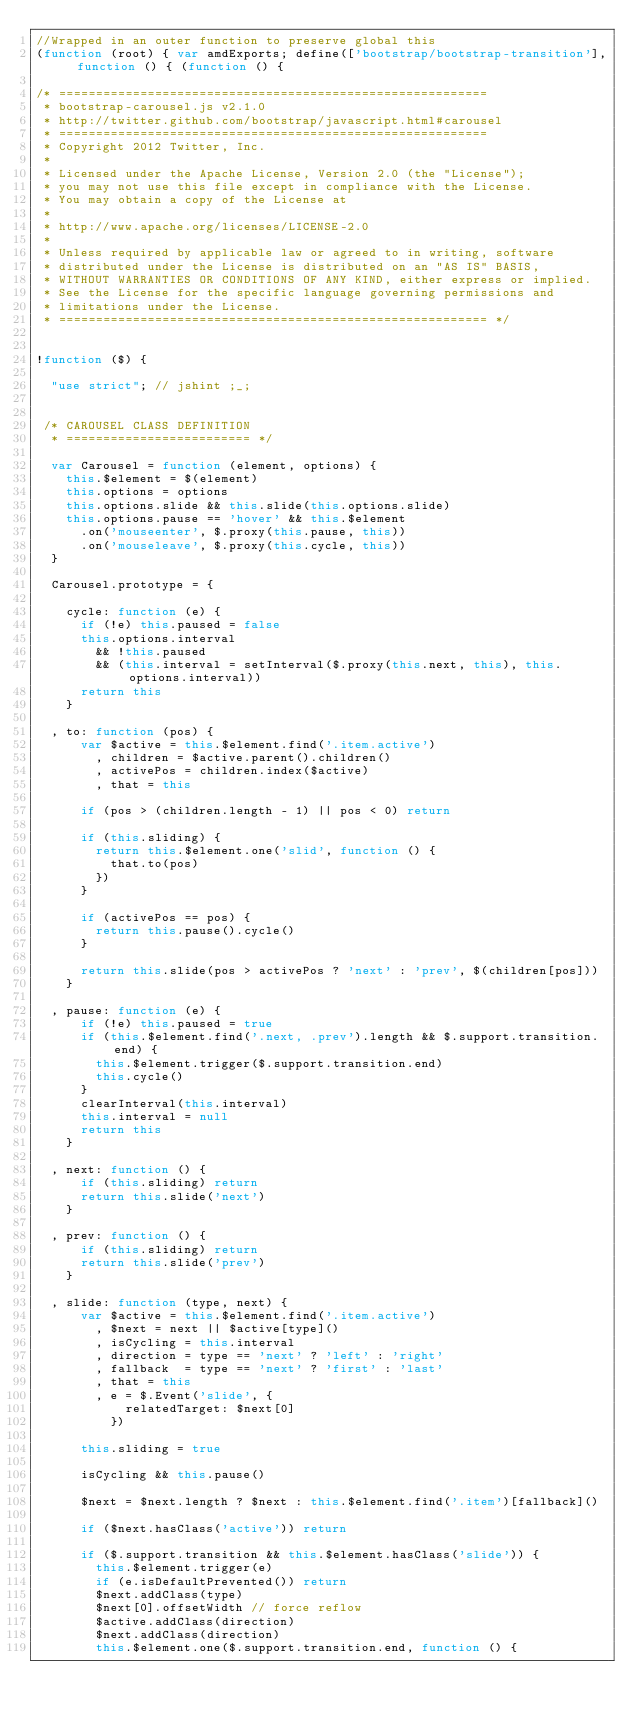<code> <loc_0><loc_0><loc_500><loc_500><_JavaScript_>//Wrapped in an outer function to preserve global this
(function (root) { var amdExports; define(['bootstrap/bootstrap-transition'], function () { (function () {

/* ==========================================================
 * bootstrap-carousel.js v2.1.0
 * http://twitter.github.com/bootstrap/javascript.html#carousel
 * ==========================================================
 * Copyright 2012 Twitter, Inc.
 *
 * Licensed under the Apache License, Version 2.0 (the "License");
 * you may not use this file except in compliance with the License.
 * You may obtain a copy of the License at
 *
 * http://www.apache.org/licenses/LICENSE-2.0
 *
 * Unless required by applicable law or agreed to in writing, software
 * distributed under the License is distributed on an "AS IS" BASIS,
 * WITHOUT WARRANTIES OR CONDITIONS OF ANY KIND, either express or implied.
 * See the License for the specific language governing permissions and
 * limitations under the License.
 * ========================================================== */


!function ($) {

  "use strict"; // jshint ;_;


 /* CAROUSEL CLASS DEFINITION
  * ========================= */

  var Carousel = function (element, options) {
    this.$element = $(element)
    this.options = options
    this.options.slide && this.slide(this.options.slide)
    this.options.pause == 'hover' && this.$element
      .on('mouseenter', $.proxy(this.pause, this))
      .on('mouseleave', $.proxy(this.cycle, this))
  }

  Carousel.prototype = {

    cycle: function (e) {
      if (!e) this.paused = false
      this.options.interval
        && !this.paused
        && (this.interval = setInterval($.proxy(this.next, this), this.options.interval))
      return this
    }

  , to: function (pos) {
      var $active = this.$element.find('.item.active')
        , children = $active.parent().children()
        , activePos = children.index($active)
        , that = this

      if (pos > (children.length - 1) || pos < 0) return

      if (this.sliding) {
        return this.$element.one('slid', function () {
          that.to(pos)
        })
      }

      if (activePos == pos) {
        return this.pause().cycle()
      }

      return this.slide(pos > activePos ? 'next' : 'prev', $(children[pos]))
    }

  , pause: function (e) {
      if (!e) this.paused = true
      if (this.$element.find('.next, .prev').length && $.support.transition.end) {
        this.$element.trigger($.support.transition.end)
        this.cycle()
      }
      clearInterval(this.interval)
      this.interval = null
      return this
    }

  , next: function () {
      if (this.sliding) return
      return this.slide('next')
    }

  , prev: function () {
      if (this.sliding) return
      return this.slide('prev')
    }

  , slide: function (type, next) {
      var $active = this.$element.find('.item.active')
        , $next = next || $active[type]()
        , isCycling = this.interval
        , direction = type == 'next' ? 'left' : 'right'
        , fallback  = type == 'next' ? 'first' : 'last'
        , that = this
        , e = $.Event('slide', {
            relatedTarget: $next[0]
          })

      this.sliding = true

      isCycling && this.pause()

      $next = $next.length ? $next : this.$element.find('.item')[fallback]()

      if ($next.hasClass('active')) return

      if ($.support.transition && this.$element.hasClass('slide')) {
        this.$element.trigger(e)
        if (e.isDefaultPrevented()) return
        $next.addClass(type)
        $next[0].offsetWidth // force reflow
        $active.addClass(direction)
        $next.addClass(direction)
        this.$element.one($.support.transition.end, function () {</code> 